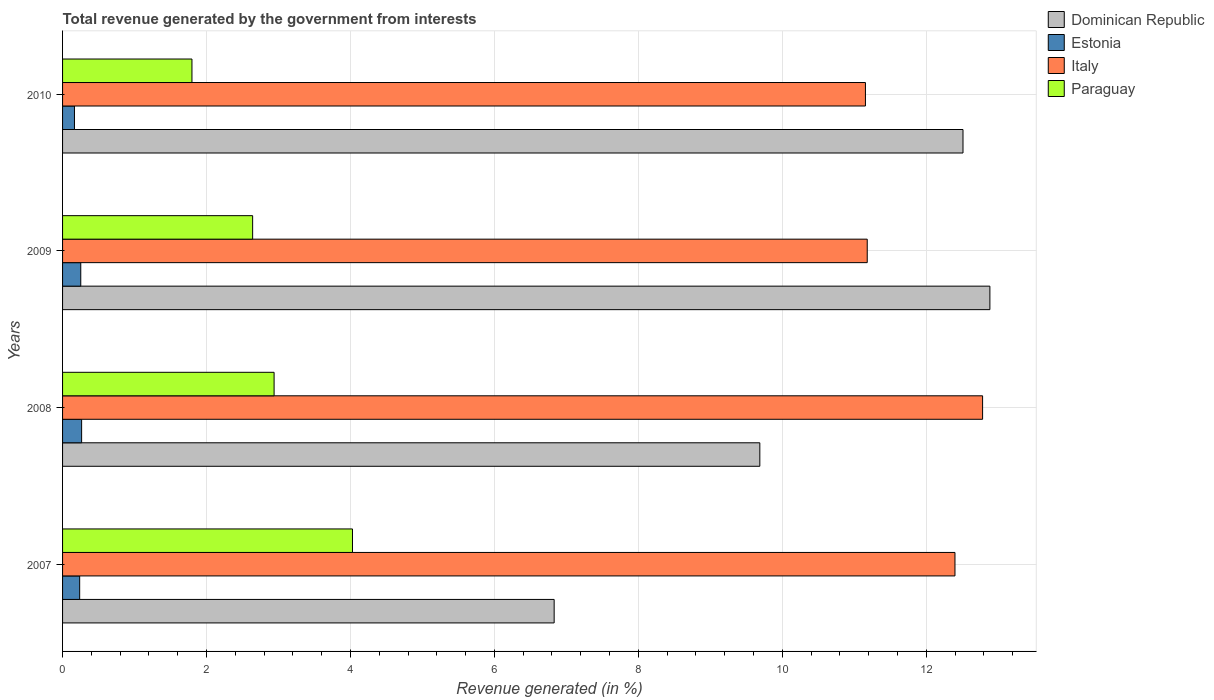How many different coloured bars are there?
Your answer should be compact. 4. Are the number of bars per tick equal to the number of legend labels?
Your answer should be very brief. Yes. How many bars are there on the 1st tick from the bottom?
Provide a succinct answer. 4. What is the label of the 2nd group of bars from the top?
Make the answer very short. 2009. In how many cases, is the number of bars for a given year not equal to the number of legend labels?
Your answer should be compact. 0. What is the total revenue generated in Dominican Republic in 2009?
Your answer should be very brief. 12.88. Across all years, what is the maximum total revenue generated in Dominican Republic?
Give a very brief answer. 12.88. Across all years, what is the minimum total revenue generated in Italy?
Make the answer very short. 11.16. In which year was the total revenue generated in Dominican Republic minimum?
Make the answer very short. 2007. What is the total total revenue generated in Paraguay in the graph?
Offer a terse response. 11.41. What is the difference between the total revenue generated in Estonia in 2007 and that in 2009?
Your answer should be compact. -0.02. What is the difference between the total revenue generated in Dominican Republic in 2009 and the total revenue generated in Italy in 2008?
Keep it short and to the point. 0.1. What is the average total revenue generated in Italy per year?
Ensure brevity in your answer.  11.88. In the year 2007, what is the difference between the total revenue generated in Paraguay and total revenue generated in Estonia?
Give a very brief answer. 3.79. In how many years, is the total revenue generated in Estonia greater than 9.2 %?
Ensure brevity in your answer.  0. What is the ratio of the total revenue generated in Italy in 2007 to that in 2009?
Give a very brief answer. 1.11. Is the total revenue generated in Dominican Republic in 2008 less than that in 2009?
Your answer should be compact. Yes. Is the difference between the total revenue generated in Paraguay in 2007 and 2008 greater than the difference between the total revenue generated in Estonia in 2007 and 2008?
Offer a terse response. Yes. What is the difference between the highest and the second highest total revenue generated in Dominican Republic?
Your response must be concise. 0.37. What is the difference between the highest and the lowest total revenue generated in Dominican Republic?
Offer a terse response. 6.05. What does the 3rd bar from the top in 2008 represents?
Your response must be concise. Estonia. What does the 1st bar from the bottom in 2007 represents?
Make the answer very short. Dominican Republic. Does the graph contain any zero values?
Your response must be concise. No. Where does the legend appear in the graph?
Offer a terse response. Top right. What is the title of the graph?
Your answer should be compact. Total revenue generated by the government from interests. What is the label or title of the X-axis?
Your answer should be compact. Revenue generated (in %). What is the Revenue generated (in %) of Dominican Republic in 2007?
Provide a succinct answer. 6.83. What is the Revenue generated (in %) of Estonia in 2007?
Keep it short and to the point. 0.24. What is the Revenue generated (in %) in Italy in 2007?
Your answer should be very brief. 12.4. What is the Revenue generated (in %) of Paraguay in 2007?
Keep it short and to the point. 4.03. What is the Revenue generated (in %) of Dominican Republic in 2008?
Offer a very short reply. 9.69. What is the Revenue generated (in %) in Estonia in 2008?
Your answer should be compact. 0.26. What is the Revenue generated (in %) of Italy in 2008?
Ensure brevity in your answer.  12.78. What is the Revenue generated (in %) of Paraguay in 2008?
Your answer should be compact. 2.94. What is the Revenue generated (in %) in Dominican Republic in 2009?
Make the answer very short. 12.88. What is the Revenue generated (in %) of Estonia in 2009?
Keep it short and to the point. 0.25. What is the Revenue generated (in %) of Italy in 2009?
Ensure brevity in your answer.  11.18. What is the Revenue generated (in %) of Paraguay in 2009?
Your answer should be very brief. 2.64. What is the Revenue generated (in %) of Dominican Republic in 2010?
Your answer should be compact. 12.51. What is the Revenue generated (in %) of Estonia in 2010?
Ensure brevity in your answer.  0.17. What is the Revenue generated (in %) of Italy in 2010?
Ensure brevity in your answer.  11.16. What is the Revenue generated (in %) in Paraguay in 2010?
Make the answer very short. 1.8. Across all years, what is the maximum Revenue generated (in %) in Dominican Republic?
Keep it short and to the point. 12.88. Across all years, what is the maximum Revenue generated (in %) of Estonia?
Your response must be concise. 0.26. Across all years, what is the maximum Revenue generated (in %) in Italy?
Your answer should be compact. 12.78. Across all years, what is the maximum Revenue generated (in %) of Paraguay?
Give a very brief answer. 4.03. Across all years, what is the minimum Revenue generated (in %) in Dominican Republic?
Keep it short and to the point. 6.83. Across all years, what is the minimum Revenue generated (in %) in Estonia?
Provide a short and direct response. 0.17. Across all years, what is the minimum Revenue generated (in %) of Italy?
Your answer should be compact. 11.16. Across all years, what is the minimum Revenue generated (in %) in Paraguay?
Your answer should be very brief. 1.8. What is the total Revenue generated (in %) in Dominican Republic in the graph?
Your response must be concise. 41.91. What is the total Revenue generated (in %) in Estonia in the graph?
Offer a very short reply. 0.92. What is the total Revenue generated (in %) in Italy in the graph?
Your answer should be compact. 47.52. What is the total Revenue generated (in %) in Paraguay in the graph?
Give a very brief answer. 11.41. What is the difference between the Revenue generated (in %) of Dominican Republic in 2007 and that in 2008?
Your answer should be compact. -2.86. What is the difference between the Revenue generated (in %) in Estonia in 2007 and that in 2008?
Provide a succinct answer. -0.03. What is the difference between the Revenue generated (in %) of Italy in 2007 and that in 2008?
Your answer should be very brief. -0.38. What is the difference between the Revenue generated (in %) in Paraguay in 2007 and that in 2008?
Offer a terse response. 1.09. What is the difference between the Revenue generated (in %) in Dominican Republic in 2007 and that in 2009?
Offer a very short reply. -6.05. What is the difference between the Revenue generated (in %) of Estonia in 2007 and that in 2009?
Provide a short and direct response. -0.02. What is the difference between the Revenue generated (in %) in Italy in 2007 and that in 2009?
Your answer should be compact. 1.22. What is the difference between the Revenue generated (in %) of Paraguay in 2007 and that in 2009?
Your answer should be very brief. 1.39. What is the difference between the Revenue generated (in %) in Dominican Republic in 2007 and that in 2010?
Ensure brevity in your answer.  -5.68. What is the difference between the Revenue generated (in %) of Estonia in 2007 and that in 2010?
Your answer should be compact. 0.07. What is the difference between the Revenue generated (in %) in Italy in 2007 and that in 2010?
Offer a terse response. 1.24. What is the difference between the Revenue generated (in %) of Paraguay in 2007 and that in 2010?
Ensure brevity in your answer.  2.23. What is the difference between the Revenue generated (in %) in Dominican Republic in 2008 and that in 2009?
Provide a short and direct response. -3.2. What is the difference between the Revenue generated (in %) in Estonia in 2008 and that in 2009?
Your answer should be compact. 0.01. What is the difference between the Revenue generated (in %) in Italy in 2008 and that in 2009?
Offer a terse response. 1.6. What is the difference between the Revenue generated (in %) in Paraguay in 2008 and that in 2009?
Your response must be concise. 0.3. What is the difference between the Revenue generated (in %) of Dominican Republic in 2008 and that in 2010?
Provide a succinct answer. -2.82. What is the difference between the Revenue generated (in %) of Estonia in 2008 and that in 2010?
Offer a terse response. 0.1. What is the difference between the Revenue generated (in %) of Italy in 2008 and that in 2010?
Offer a very short reply. 1.63. What is the difference between the Revenue generated (in %) of Paraguay in 2008 and that in 2010?
Your answer should be very brief. 1.14. What is the difference between the Revenue generated (in %) in Dominican Republic in 2009 and that in 2010?
Offer a very short reply. 0.37. What is the difference between the Revenue generated (in %) in Estonia in 2009 and that in 2010?
Offer a terse response. 0.09. What is the difference between the Revenue generated (in %) in Italy in 2009 and that in 2010?
Provide a short and direct response. 0.02. What is the difference between the Revenue generated (in %) of Paraguay in 2009 and that in 2010?
Offer a terse response. 0.84. What is the difference between the Revenue generated (in %) of Dominican Republic in 2007 and the Revenue generated (in %) of Estonia in 2008?
Give a very brief answer. 6.57. What is the difference between the Revenue generated (in %) in Dominican Republic in 2007 and the Revenue generated (in %) in Italy in 2008?
Your response must be concise. -5.95. What is the difference between the Revenue generated (in %) of Dominican Republic in 2007 and the Revenue generated (in %) of Paraguay in 2008?
Provide a succinct answer. 3.89. What is the difference between the Revenue generated (in %) in Estonia in 2007 and the Revenue generated (in %) in Italy in 2008?
Provide a succinct answer. -12.55. What is the difference between the Revenue generated (in %) in Estonia in 2007 and the Revenue generated (in %) in Paraguay in 2008?
Provide a short and direct response. -2.7. What is the difference between the Revenue generated (in %) in Italy in 2007 and the Revenue generated (in %) in Paraguay in 2008?
Provide a succinct answer. 9.46. What is the difference between the Revenue generated (in %) of Dominican Republic in 2007 and the Revenue generated (in %) of Estonia in 2009?
Make the answer very short. 6.58. What is the difference between the Revenue generated (in %) in Dominican Republic in 2007 and the Revenue generated (in %) in Italy in 2009?
Provide a short and direct response. -4.35. What is the difference between the Revenue generated (in %) of Dominican Republic in 2007 and the Revenue generated (in %) of Paraguay in 2009?
Ensure brevity in your answer.  4.19. What is the difference between the Revenue generated (in %) of Estonia in 2007 and the Revenue generated (in %) of Italy in 2009?
Provide a succinct answer. -10.94. What is the difference between the Revenue generated (in %) of Estonia in 2007 and the Revenue generated (in %) of Paraguay in 2009?
Provide a short and direct response. -2.4. What is the difference between the Revenue generated (in %) in Italy in 2007 and the Revenue generated (in %) in Paraguay in 2009?
Keep it short and to the point. 9.76. What is the difference between the Revenue generated (in %) in Dominican Republic in 2007 and the Revenue generated (in %) in Estonia in 2010?
Provide a short and direct response. 6.66. What is the difference between the Revenue generated (in %) of Dominican Republic in 2007 and the Revenue generated (in %) of Italy in 2010?
Provide a succinct answer. -4.33. What is the difference between the Revenue generated (in %) in Dominican Republic in 2007 and the Revenue generated (in %) in Paraguay in 2010?
Your answer should be very brief. 5.03. What is the difference between the Revenue generated (in %) of Estonia in 2007 and the Revenue generated (in %) of Italy in 2010?
Offer a terse response. -10.92. What is the difference between the Revenue generated (in %) of Estonia in 2007 and the Revenue generated (in %) of Paraguay in 2010?
Your answer should be very brief. -1.56. What is the difference between the Revenue generated (in %) in Italy in 2007 and the Revenue generated (in %) in Paraguay in 2010?
Ensure brevity in your answer.  10.6. What is the difference between the Revenue generated (in %) of Dominican Republic in 2008 and the Revenue generated (in %) of Estonia in 2009?
Offer a terse response. 9.44. What is the difference between the Revenue generated (in %) of Dominican Republic in 2008 and the Revenue generated (in %) of Italy in 2009?
Your answer should be very brief. -1.49. What is the difference between the Revenue generated (in %) in Dominican Republic in 2008 and the Revenue generated (in %) in Paraguay in 2009?
Make the answer very short. 7.05. What is the difference between the Revenue generated (in %) of Estonia in 2008 and the Revenue generated (in %) of Italy in 2009?
Offer a very short reply. -10.92. What is the difference between the Revenue generated (in %) in Estonia in 2008 and the Revenue generated (in %) in Paraguay in 2009?
Offer a terse response. -2.38. What is the difference between the Revenue generated (in %) in Italy in 2008 and the Revenue generated (in %) in Paraguay in 2009?
Give a very brief answer. 10.14. What is the difference between the Revenue generated (in %) of Dominican Republic in 2008 and the Revenue generated (in %) of Estonia in 2010?
Keep it short and to the point. 9.52. What is the difference between the Revenue generated (in %) of Dominican Republic in 2008 and the Revenue generated (in %) of Italy in 2010?
Your answer should be compact. -1.47. What is the difference between the Revenue generated (in %) of Dominican Republic in 2008 and the Revenue generated (in %) of Paraguay in 2010?
Keep it short and to the point. 7.89. What is the difference between the Revenue generated (in %) in Estonia in 2008 and the Revenue generated (in %) in Italy in 2010?
Give a very brief answer. -10.89. What is the difference between the Revenue generated (in %) of Estonia in 2008 and the Revenue generated (in %) of Paraguay in 2010?
Your response must be concise. -1.53. What is the difference between the Revenue generated (in %) of Italy in 2008 and the Revenue generated (in %) of Paraguay in 2010?
Give a very brief answer. 10.99. What is the difference between the Revenue generated (in %) in Dominican Republic in 2009 and the Revenue generated (in %) in Estonia in 2010?
Give a very brief answer. 12.72. What is the difference between the Revenue generated (in %) in Dominican Republic in 2009 and the Revenue generated (in %) in Italy in 2010?
Ensure brevity in your answer.  1.73. What is the difference between the Revenue generated (in %) in Dominican Republic in 2009 and the Revenue generated (in %) in Paraguay in 2010?
Keep it short and to the point. 11.09. What is the difference between the Revenue generated (in %) of Estonia in 2009 and the Revenue generated (in %) of Italy in 2010?
Your answer should be very brief. -10.9. What is the difference between the Revenue generated (in %) in Estonia in 2009 and the Revenue generated (in %) in Paraguay in 2010?
Give a very brief answer. -1.54. What is the difference between the Revenue generated (in %) in Italy in 2009 and the Revenue generated (in %) in Paraguay in 2010?
Offer a very short reply. 9.38. What is the average Revenue generated (in %) in Dominican Republic per year?
Your answer should be very brief. 10.48. What is the average Revenue generated (in %) in Estonia per year?
Your response must be concise. 0.23. What is the average Revenue generated (in %) of Italy per year?
Your answer should be compact. 11.88. What is the average Revenue generated (in %) in Paraguay per year?
Provide a short and direct response. 2.85. In the year 2007, what is the difference between the Revenue generated (in %) of Dominican Republic and Revenue generated (in %) of Estonia?
Your answer should be compact. 6.59. In the year 2007, what is the difference between the Revenue generated (in %) in Dominican Republic and Revenue generated (in %) in Italy?
Offer a very short reply. -5.57. In the year 2007, what is the difference between the Revenue generated (in %) in Dominican Republic and Revenue generated (in %) in Paraguay?
Your answer should be compact. 2.8. In the year 2007, what is the difference between the Revenue generated (in %) in Estonia and Revenue generated (in %) in Italy?
Make the answer very short. -12.16. In the year 2007, what is the difference between the Revenue generated (in %) in Estonia and Revenue generated (in %) in Paraguay?
Offer a terse response. -3.79. In the year 2007, what is the difference between the Revenue generated (in %) of Italy and Revenue generated (in %) of Paraguay?
Offer a very short reply. 8.37. In the year 2008, what is the difference between the Revenue generated (in %) of Dominican Republic and Revenue generated (in %) of Estonia?
Give a very brief answer. 9.42. In the year 2008, what is the difference between the Revenue generated (in %) in Dominican Republic and Revenue generated (in %) in Italy?
Offer a terse response. -3.1. In the year 2008, what is the difference between the Revenue generated (in %) of Dominican Republic and Revenue generated (in %) of Paraguay?
Your response must be concise. 6.75. In the year 2008, what is the difference between the Revenue generated (in %) in Estonia and Revenue generated (in %) in Italy?
Make the answer very short. -12.52. In the year 2008, what is the difference between the Revenue generated (in %) of Estonia and Revenue generated (in %) of Paraguay?
Offer a terse response. -2.67. In the year 2008, what is the difference between the Revenue generated (in %) of Italy and Revenue generated (in %) of Paraguay?
Give a very brief answer. 9.84. In the year 2009, what is the difference between the Revenue generated (in %) in Dominican Republic and Revenue generated (in %) in Estonia?
Offer a terse response. 12.63. In the year 2009, what is the difference between the Revenue generated (in %) in Dominican Republic and Revenue generated (in %) in Italy?
Your answer should be compact. 1.7. In the year 2009, what is the difference between the Revenue generated (in %) in Dominican Republic and Revenue generated (in %) in Paraguay?
Your answer should be very brief. 10.24. In the year 2009, what is the difference between the Revenue generated (in %) in Estonia and Revenue generated (in %) in Italy?
Give a very brief answer. -10.93. In the year 2009, what is the difference between the Revenue generated (in %) in Estonia and Revenue generated (in %) in Paraguay?
Keep it short and to the point. -2.39. In the year 2009, what is the difference between the Revenue generated (in %) of Italy and Revenue generated (in %) of Paraguay?
Make the answer very short. 8.54. In the year 2010, what is the difference between the Revenue generated (in %) of Dominican Republic and Revenue generated (in %) of Estonia?
Give a very brief answer. 12.35. In the year 2010, what is the difference between the Revenue generated (in %) of Dominican Republic and Revenue generated (in %) of Italy?
Your response must be concise. 1.36. In the year 2010, what is the difference between the Revenue generated (in %) of Dominican Republic and Revenue generated (in %) of Paraguay?
Make the answer very short. 10.71. In the year 2010, what is the difference between the Revenue generated (in %) in Estonia and Revenue generated (in %) in Italy?
Offer a very short reply. -10.99. In the year 2010, what is the difference between the Revenue generated (in %) of Estonia and Revenue generated (in %) of Paraguay?
Make the answer very short. -1.63. In the year 2010, what is the difference between the Revenue generated (in %) of Italy and Revenue generated (in %) of Paraguay?
Make the answer very short. 9.36. What is the ratio of the Revenue generated (in %) of Dominican Republic in 2007 to that in 2008?
Offer a terse response. 0.7. What is the ratio of the Revenue generated (in %) in Estonia in 2007 to that in 2008?
Offer a terse response. 0.9. What is the ratio of the Revenue generated (in %) of Italy in 2007 to that in 2008?
Keep it short and to the point. 0.97. What is the ratio of the Revenue generated (in %) of Paraguay in 2007 to that in 2008?
Your response must be concise. 1.37. What is the ratio of the Revenue generated (in %) in Dominican Republic in 2007 to that in 2009?
Ensure brevity in your answer.  0.53. What is the ratio of the Revenue generated (in %) of Estonia in 2007 to that in 2009?
Provide a short and direct response. 0.94. What is the ratio of the Revenue generated (in %) in Italy in 2007 to that in 2009?
Keep it short and to the point. 1.11. What is the ratio of the Revenue generated (in %) of Paraguay in 2007 to that in 2009?
Ensure brevity in your answer.  1.53. What is the ratio of the Revenue generated (in %) of Dominican Republic in 2007 to that in 2010?
Ensure brevity in your answer.  0.55. What is the ratio of the Revenue generated (in %) in Estonia in 2007 to that in 2010?
Your response must be concise. 1.44. What is the ratio of the Revenue generated (in %) of Italy in 2007 to that in 2010?
Ensure brevity in your answer.  1.11. What is the ratio of the Revenue generated (in %) of Paraguay in 2007 to that in 2010?
Your response must be concise. 2.24. What is the ratio of the Revenue generated (in %) of Dominican Republic in 2008 to that in 2009?
Provide a short and direct response. 0.75. What is the ratio of the Revenue generated (in %) in Estonia in 2008 to that in 2009?
Your response must be concise. 1.05. What is the ratio of the Revenue generated (in %) of Italy in 2008 to that in 2009?
Offer a very short reply. 1.14. What is the ratio of the Revenue generated (in %) of Paraguay in 2008 to that in 2009?
Provide a short and direct response. 1.11. What is the ratio of the Revenue generated (in %) in Dominican Republic in 2008 to that in 2010?
Offer a terse response. 0.77. What is the ratio of the Revenue generated (in %) in Estonia in 2008 to that in 2010?
Your answer should be very brief. 1.6. What is the ratio of the Revenue generated (in %) in Italy in 2008 to that in 2010?
Provide a short and direct response. 1.15. What is the ratio of the Revenue generated (in %) of Paraguay in 2008 to that in 2010?
Your answer should be very brief. 1.63. What is the ratio of the Revenue generated (in %) of Dominican Republic in 2009 to that in 2010?
Ensure brevity in your answer.  1.03. What is the ratio of the Revenue generated (in %) of Estonia in 2009 to that in 2010?
Your answer should be compact. 1.53. What is the ratio of the Revenue generated (in %) in Paraguay in 2009 to that in 2010?
Make the answer very short. 1.47. What is the difference between the highest and the second highest Revenue generated (in %) in Dominican Republic?
Your response must be concise. 0.37. What is the difference between the highest and the second highest Revenue generated (in %) in Estonia?
Provide a short and direct response. 0.01. What is the difference between the highest and the second highest Revenue generated (in %) in Italy?
Make the answer very short. 0.38. What is the difference between the highest and the second highest Revenue generated (in %) in Paraguay?
Ensure brevity in your answer.  1.09. What is the difference between the highest and the lowest Revenue generated (in %) of Dominican Republic?
Ensure brevity in your answer.  6.05. What is the difference between the highest and the lowest Revenue generated (in %) in Estonia?
Offer a very short reply. 0.1. What is the difference between the highest and the lowest Revenue generated (in %) of Italy?
Your response must be concise. 1.63. What is the difference between the highest and the lowest Revenue generated (in %) in Paraguay?
Your answer should be compact. 2.23. 